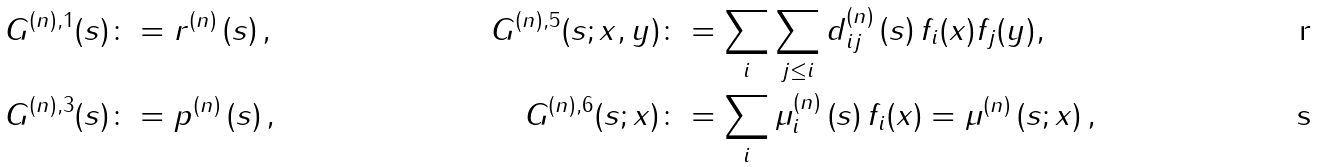Convert formula to latex. <formula><loc_0><loc_0><loc_500><loc_500>& G ^ { ( n ) , 1 } ( s ) \colon = r ^ { ( n ) } \left ( s \right ) , & G ^ { ( n ) , 5 } ( s ; x , y ) & \colon = \sum _ { i } \sum _ { j \leq i } d ^ { ( n ) } _ { i j } \left ( s \right ) f _ { i } ( x ) f _ { j } ( y ) , \\ & G ^ { ( n ) , 3 } ( s ) \colon = p ^ { ( n ) } \left ( s \right ) , & G ^ { ( n ) , 6 } ( s ; x ) & \colon = \sum _ { i } \mu ^ { ( n ) } _ { i } \left ( s \right ) f _ { i } ( x ) = \mu ^ { ( n ) } \left ( s ; x \right ) ,</formula> 